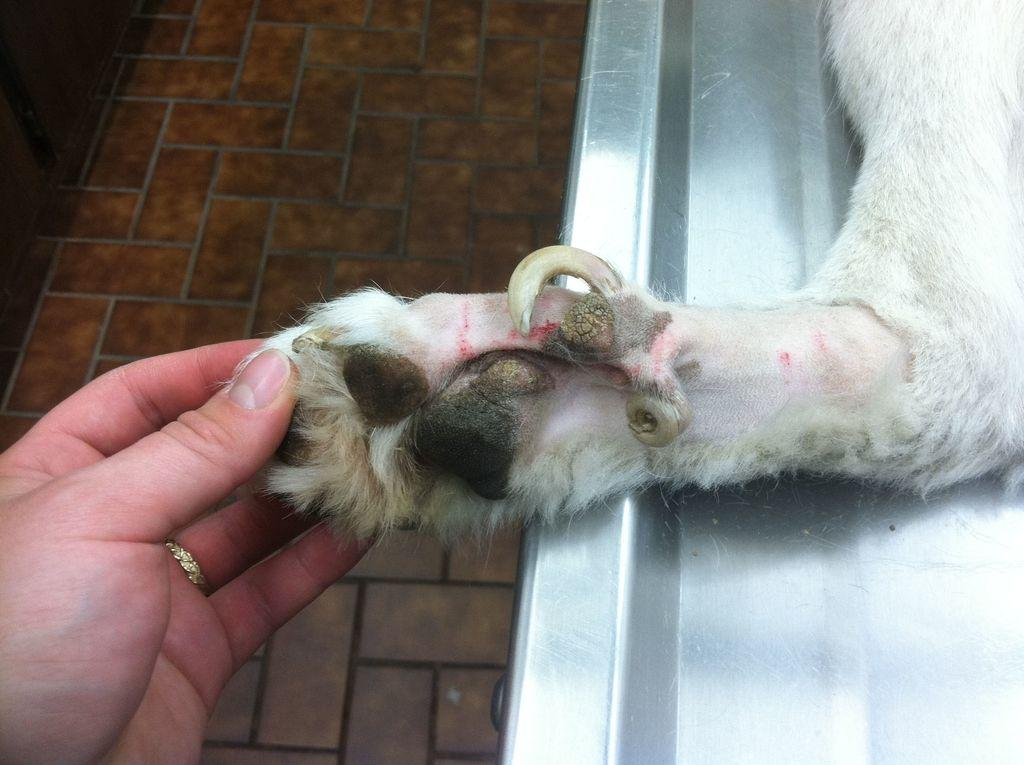Who or what is present in the image? There is a person in the image. What is the person doing in the image? The person is holding the leg of an animal. What type of government is depicted in the image? There is no depiction of a government in the image; it features a person holding the leg of an animal. 